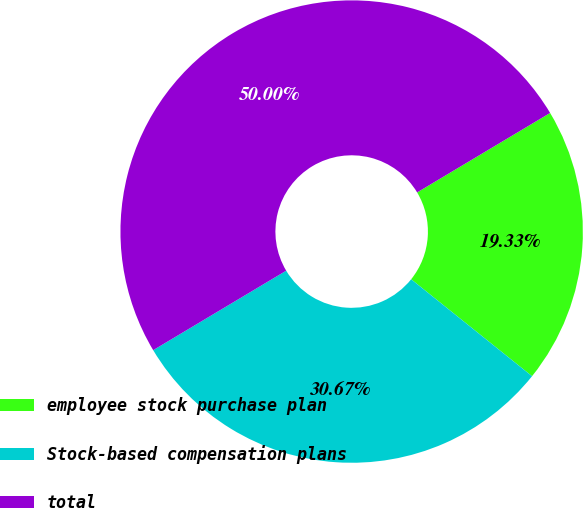<chart> <loc_0><loc_0><loc_500><loc_500><pie_chart><fcel>employee stock purchase plan<fcel>Stock-based compensation plans<fcel>total<nl><fcel>19.33%<fcel>30.67%<fcel>50.0%<nl></chart> 